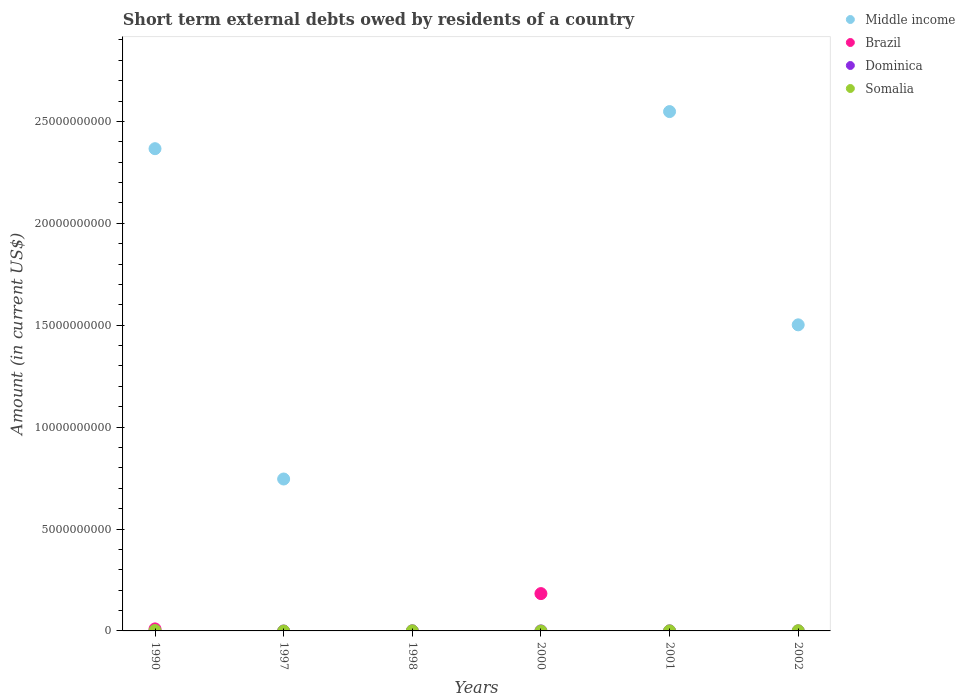How many different coloured dotlines are there?
Your answer should be compact. 4. What is the amount of short-term external debts owed by residents in Middle income in 1997?
Keep it short and to the point. 7.45e+09. Across all years, what is the maximum amount of short-term external debts owed by residents in Somalia?
Provide a short and direct response. 1.77e+07. What is the total amount of short-term external debts owed by residents in Middle income in the graph?
Give a very brief answer. 7.16e+1. What is the difference between the amount of short-term external debts owed by residents in Dominica in 1990 and that in 2001?
Offer a terse response. -2.87e+06. What is the average amount of short-term external debts owed by residents in Somalia per year?
Offer a very short reply. 5.63e+06. In the year 2002, what is the difference between the amount of short-term external debts owed by residents in Dominica and amount of short-term external debts owed by residents in Middle income?
Provide a short and direct response. -1.50e+1. In how many years, is the amount of short-term external debts owed by residents in Somalia greater than 16000000000 US$?
Provide a succinct answer. 0. What is the ratio of the amount of short-term external debts owed by residents in Dominica in 1990 to that in 2000?
Ensure brevity in your answer.  0.65. Is the difference between the amount of short-term external debts owed by residents in Dominica in 2001 and 2002 greater than the difference between the amount of short-term external debts owed by residents in Middle income in 2001 and 2002?
Provide a short and direct response. No. What is the difference between the highest and the second highest amount of short-term external debts owed by residents in Somalia?
Give a very brief answer. 8.66e+06. What is the difference between the highest and the lowest amount of short-term external debts owed by residents in Somalia?
Give a very brief answer. 1.77e+07. In how many years, is the amount of short-term external debts owed by residents in Brazil greater than the average amount of short-term external debts owed by residents in Brazil taken over all years?
Offer a terse response. 1. Is it the case that in every year, the sum of the amount of short-term external debts owed by residents in Brazil and amount of short-term external debts owed by residents in Dominica  is greater than the sum of amount of short-term external debts owed by residents in Middle income and amount of short-term external debts owed by residents in Somalia?
Your answer should be very brief. No. Is it the case that in every year, the sum of the amount of short-term external debts owed by residents in Somalia and amount of short-term external debts owed by residents in Middle income  is greater than the amount of short-term external debts owed by residents in Dominica?
Your response must be concise. No. How many dotlines are there?
Give a very brief answer. 4. Are the values on the major ticks of Y-axis written in scientific E-notation?
Give a very brief answer. No. Does the graph contain grids?
Make the answer very short. No. How many legend labels are there?
Your response must be concise. 4. How are the legend labels stacked?
Provide a short and direct response. Vertical. What is the title of the graph?
Give a very brief answer. Short term external debts owed by residents of a country. Does "Afghanistan" appear as one of the legend labels in the graph?
Ensure brevity in your answer.  No. What is the label or title of the X-axis?
Make the answer very short. Years. What is the label or title of the Y-axis?
Provide a short and direct response. Amount (in current US$). What is the Amount (in current US$) in Middle income in 1990?
Offer a terse response. 2.37e+1. What is the Amount (in current US$) in Brazil in 1990?
Your response must be concise. 9.90e+07. What is the Amount (in current US$) in Somalia in 1990?
Ensure brevity in your answer.  1.77e+07. What is the Amount (in current US$) in Middle income in 1997?
Ensure brevity in your answer.  7.45e+09. What is the Amount (in current US$) of Somalia in 1997?
Make the answer very short. 0. What is the Amount (in current US$) of Dominica in 1998?
Provide a succinct answer. 5.84e+06. What is the Amount (in current US$) in Brazil in 2000?
Your response must be concise. 1.83e+09. What is the Amount (in current US$) of Middle income in 2001?
Keep it short and to the point. 2.55e+1. What is the Amount (in current US$) of Brazil in 2001?
Your answer should be very brief. 0. What is the Amount (in current US$) in Middle income in 2002?
Provide a succinct answer. 1.50e+1. What is the Amount (in current US$) in Dominica in 2002?
Provide a short and direct response. 1.50e+06. What is the Amount (in current US$) in Somalia in 2002?
Give a very brief answer. 9.06e+06. Across all years, what is the maximum Amount (in current US$) in Middle income?
Keep it short and to the point. 2.55e+1. Across all years, what is the maximum Amount (in current US$) of Brazil?
Your answer should be compact. 1.83e+09. Across all years, what is the maximum Amount (in current US$) in Dominica?
Offer a terse response. 5.84e+06. Across all years, what is the maximum Amount (in current US$) in Somalia?
Provide a succinct answer. 1.77e+07. Across all years, what is the minimum Amount (in current US$) of Middle income?
Provide a short and direct response. 0. Across all years, what is the minimum Amount (in current US$) in Brazil?
Your answer should be compact. 0. Across all years, what is the minimum Amount (in current US$) in Dominica?
Provide a short and direct response. 0. What is the total Amount (in current US$) in Middle income in the graph?
Offer a very short reply. 7.16e+1. What is the total Amount (in current US$) in Brazil in the graph?
Give a very brief answer. 1.93e+09. What is the total Amount (in current US$) in Dominica in the graph?
Offer a terse response. 1.07e+07. What is the total Amount (in current US$) of Somalia in the graph?
Give a very brief answer. 3.38e+07. What is the difference between the Amount (in current US$) of Middle income in 1990 and that in 1997?
Your response must be concise. 1.62e+1. What is the difference between the Amount (in current US$) in Dominica in 1990 and that in 1998?
Make the answer very short. -5.71e+06. What is the difference between the Amount (in current US$) of Somalia in 1990 and that in 1998?
Give a very brief answer. 1.27e+07. What is the difference between the Amount (in current US$) in Brazil in 1990 and that in 2000?
Make the answer very short. -1.73e+09. What is the difference between the Amount (in current US$) in Middle income in 1990 and that in 2001?
Offer a terse response. -1.82e+09. What is the difference between the Amount (in current US$) of Dominica in 1990 and that in 2001?
Make the answer very short. -2.87e+06. What is the difference between the Amount (in current US$) of Somalia in 1990 and that in 2001?
Provide a short and direct response. 1.57e+07. What is the difference between the Amount (in current US$) in Middle income in 1990 and that in 2002?
Provide a short and direct response. 8.64e+09. What is the difference between the Amount (in current US$) of Dominica in 1990 and that in 2002?
Offer a very short reply. -1.37e+06. What is the difference between the Amount (in current US$) of Somalia in 1990 and that in 2002?
Offer a terse response. 8.66e+06. What is the difference between the Amount (in current US$) in Middle income in 1997 and that in 2001?
Give a very brief answer. -1.80e+1. What is the difference between the Amount (in current US$) in Middle income in 1997 and that in 2002?
Offer a very short reply. -7.56e+09. What is the difference between the Amount (in current US$) of Dominica in 1998 and that in 2000?
Ensure brevity in your answer.  5.64e+06. What is the difference between the Amount (in current US$) in Dominica in 1998 and that in 2001?
Give a very brief answer. 2.84e+06. What is the difference between the Amount (in current US$) of Dominica in 1998 and that in 2002?
Provide a succinct answer. 4.34e+06. What is the difference between the Amount (in current US$) of Somalia in 1998 and that in 2002?
Provide a succinct answer. -4.06e+06. What is the difference between the Amount (in current US$) of Dominica in 2000 and that in 2001?
Offer a very short reply. -2.80e+06. What is the difference between the Amount (in current US$) of Dominica in 2000 and that in 2002?
Ensure brevity in your answer.  -1.30e+06. What is the difference between the Amount (in current US$) of Middle income in 2001 and that in 2002?
Provide a short and direct response. 1.05e+1. What is the difference between the Amount (in current US$) of Dominica in 2001 and that in 2002?
Ensure brevity in your answer.  1.50e+06. What is the difference between the Amount (in current US$) of Somalia in 2001 and that in 2002?
Provide a succinct answer. -7.06e+06. What is the difference between the Amount (in current US$) in Middle income in 1990 and the Amount (in current US$) in Dominica in 1998?
Make the answer very short. 2.37e+1. What is the difference between the Amount (in current US$) of Middle income in 1990 and the Amount (in current US$) of Somalia in 1998?
Offer a very short reply. 2.37e+1. What is the difference between the Amount (in current US$) in Brazil in 1990 and the Amount (in current US$) in Dominica in 1998?
Your answer should be very brief. 9.32e+07. What is the difference between the Amount (in current US$) in Brazil in 1990 and the Amount (in current US$) in Somalia in 1998?
Offer a very short reply. 9.40e+07. What is the difference between the Amount (in current US$) of Dominica in 1990 and the Amount (in current US$) of Somalia in 1998?
Give a very brief answer. -4.87e+06. What is the difference between the Amount (in current US$) of Middle income in 1990 and the Amount (in current US$) of Brazil in 2000?
Make the answer very short. 2.18e+1. What is the difference between the Amount (in current US$) in Middle income in 1990 and the Amount (in current US$) in Dominica in 2000?
Your answer should be compact. 2.37e+1. What is the difference between the Amount (in current US$) of Brazil in 1990 and the Amount (in current US$) of Dominica in 2000?
Give a very brief answer. 9.88e+07. What is the difference between the Amount (in current US$) of Middle income in 1990 and the Amount (in current US$) of Dominica in 2001?
Your answer should be very brief. 2.37e+1. What is the difference between the Amount (in current US$) of Middle income in 1990 and the Amount (in current US$) of Somalia in 2001?
Give a very brief answer. 2.37e+1. What is the difference between the Amount (in current US$) of Brazil in 1990 and the Amount (in current US$) of Dominica in 2001?
Your answer should be compact. 9.60e+07. What is the difference between the Amount (in current US$) in Brazil in 1990 and the Amount (in current US$) in Somalia in 2001?
Provide a short and direct response. 9.70e+07. What is the difference between the Amount (in current US$) of Dominica in 1990 and the Amount (in current US$) of Somalia in 2001?
Give a very brief answer. -1.87e+06. What is the difference between the Amount (in current US$) in Middle income in 1990 and the Amount (in current US$) in Dominica in 2002?
Your answer should be very brief. 2.37e+1. What is the difference between the Amount (in current US$) in Middle income in 1990 and the Amount (in current US$) in Somalia in 2002?
Make the answer very short. 2.37e+1. What is the difference between the Amount (in current US$) in Brazil in 1990 and the Amount (in current US$) in Dominica in 2002?
Your response must be concise. 9.75e+07. What is the difference between the Amount (in current US$) of Brazil in 1990 and the Amount (in current US$) of Somalia in 2002?
Your answer should be compact. 8.99e+07. What is the difference between the Amount (in current US$) of Dominica in 1990 and the Amount (in current US$) of Somalia in 2002?
Your answer should be very brief. -8.93e+06. What is the difference between the Amount (in current US$) of Middle income in 1997 and the Amount (in current US$) of Dominica in 1998?
Offer a very short reply. 7.45e+09. What is the difference between the Amount (in current US$) of Middle income in 1997 and the Amount (in current US$) of Somalia in 1998?
Keep it short and to the point. 7.45e+09. What is the difference between the Amount (in current US$) in Middle income in 1997 and the Amount (in current US$) in Brazil in 2000?
Make the answer very short. 5.62e+09. What is the difference between the Amount (in current US$) of Middle income in 1997 and the Amount (in current US$) of Dominica in 2000?
Provide a succinct answer. 7.45e+09. What is the difference between the Amount (in current US$) of Middle income in 1997 and the Amount (in current US$) of Dominica in 2001?
Ensure brevity in your answer.  7.45e+09. What is the difference between the Amount (in current US$) of Middle income in 1997 and the Amount (in current US$) of Somalia in 2001?
Keep it short and to the point. 7.45e+09. What is the difference between the Amount (in current US$) of Middle income in 1997 and the Amount (in current US$) of Dominica in 2002?
Your answer should be compact. 7.45e+09. What is the difference between the Amount (in current US$) of Middle income in 1997 and the Amount (in current US$) of Somalia in 2002?
Keep it short and to the point. 7.45e+09. What is the difference between the Amount (in current US$) of Dominica in 1998 and the Amount (in current US$) of Somalia in 2001?
Your answer should be very brief. 3.84e+06. What is the difference between the Amount (in current US$) in Dominica in 1998 and the Amount (in current US$) in Somalia in 2002?
Offer a very short reply. -3.22e+06. What is the difference between the Amount (in current US$) in Brazil in 2000 and the Amount (in current US$) in Dominica in 2001?
Your answer should be compact. 1.83e+09. What is the difference between the Amount (in current US$) of Brazil in 2000 and the Amount (in current US$) of Somalia in 2001?
Your response must be concise. 1.83e+09. What is the difference between the Amount (in current US$) in Dominica in 2000 and the Amount (in current US$) in Somalia in 2001?
Make the answer very short. -1.80e+06. What is the difference between the Amount (in current US$) in Brazil in 2000 and the Amount (in current US$) in Dominica in 2002?
Your response must be concise. 1.83e+09. What is the difference between the Amount (in current US$) of Brazil in 2000 and the Amount (in current US$) of Somalia in 2002?
Your response must be concise. 1.82e+09. What is the difference between the Amount (in current US$) in Dominica in 2000 and the Amount (in current US$) in Somalia in 2002?
Ensure brevity in your answer.  -8.86e+06. What is the difference between the Amount (in current US$) of Middle income in 2001 and the Amount (in current US$) of Dominica in 2002?
Your response must be concise. 2.55e+1. What is the difference between the Amount (in current US$) of Middle income in 2001 and the Amount (in current US$) of Somalia in 2002?
Your answer should be very brief. 2.55e+1. What is the difference between the Amount (in current US$) in Dominica in 2001 and the Amount (in current US$) in Somalia in 2002?
Your answer should be compact. -6.06e+06. What is the average Amount (in current US$) of Middle income per year?
Keep it short and to the point. 1.19e+1. What is the average Amount (in current US$) of Brazil per year?
Provide a short and direct response. 3.22e+08. What is the average Amount (in current US$) of Dominica per year?
Offer a terse response. 1.78e+06. What is the average Amount (in current US$) in Somalia per year?
Offer a terse response. 5.63e+06. In the year 1990, what is the difference between the Amount (in current US$) of Middle income and Amount (in current US$) of Brazil?
Ensure brevity in your answer.  2.36e+1. In the year 1990, what is the difference between the Amount (in current US$) of Middle income and Amount (in current US$) of Dominica?
Provide a short and direct response. 2.37e+1. In the year 1990, what is the difference between the Amount (in current US$) of Middle income and Amount (in current US$) of Somalia?
Offer a terse response. 2.36e+1. In the year 1990, what is the difference between the Amount (in current US$) in Brazil and Amount (in current US$) in Dominica?
Ensure brevity in your answer.  9.89e+07. In the year 1990, what is the difference between the Amount (in current US$) of Brazil and Amount (in current US$) of Somalia?
Provide a short and direct response. 8.13e+07. In the year 1990, what is the difference between the Amount (in current US$) of Dominica and Amount (in current US$) of Somalia?
Give a very brief answer. -1.76e+07. In the year 1998, what is the difference between the Amount (in current US$) of Dominica and Amount (in current US$) of Somalia?
Give a very brief answer. 8.40e+05. In the year 2000, what is the difference between the Amount (in current US$) in Brazil and Amount (in current US$) in Dominica?
Your answer should be compact. 1.83e+09. In the year 2001, what is the difference between the Amount (in current US$) in Middle income and Amount (in current US$) in Dominica?
Make the answer very short. 2.55e+1. In the year 2001, what is the difference between the Amount (in current US$) in Middle income and Amount (in current US$) in Somalia?
Give a very brief answer. 2.55e+1. In the year 2001, what is the difference between the Amount (in current US$) of Dominica and Amount (in current US$) of Somalia?
Offer a terse response. 1.00e+06. In the year 2002, what is the difference between the Amount (in current US$) in Middle income and Amount (in current US$) in Dominica?
Offer a terse response. 1.50e+1. In the year 2002, what is the difference between the Amount (in current US$) in Middle income and Amount (in current US$) in Somalia?
Offer a very short reply. 1.50e+1. In the year 2002, what is the difference between the Amount (in current US$) in Dominica and Amount (in current US$) in Somalia?
Your response must be concise. -7.56e+06. What is the ratio of the Amount (in current US$) in Middle income in 1990 to that in 1997?
Provide a succinct answer. 3.17. What is the ratio of the Amount (in current US$) in Dominica in 1990 to that in 1998?
Keep it short and to the point. 0.02. What is the ratio of the Amount (in current US$) in Somalia in 1990 to that in 1998?
Offer a terse response. 3.54. What is the ratio of the Amount (in current US$) in Brazil in 1990 to that in 2000?
Provide a short and direct response. 0.05. What is the ratio of the Amount (in current US$) in Dominica in 1990 to that in 2000?
Make the answer very short. 0.65. What is the ratio of the Amount (in current US$) in Middle income in 1990 to that in 2001?
Offer a very short reply. 0.93. What is the ratio of the Amount (in current US$) of Dominica in 1990 to that in 2001?
Offer a very short reply. 0.04. What is the ratio of the Amount (in current US$) in Somalia in 1990 to that in 2001?
Provide a succinct answer. 8.86. What is the ratio of the Amount (in current US$) in Middle income in 1990 to that in 2002?
Provide a succinct answer. 1.58. What is the ratio of the Amount (in current US$) in Dominica in 1990 to that in 2002?
Offer a terse response. 0.09. What is the ratio of the Amount (in current US$) in Somalia in 1990 to that in 2002?
Keep it short and to the point. 1.96. What is the ratio of the Amount (in current US$) of Middle income in 1997 to that in 2001?
Give a very brief answer. 0.29. What is the ratio of the Amount (in current US$) in Middle income in 1997 to that in 2002?
Offer a terse response. 0.5. What is the ratio of the Amount (in current US$) in Dominica in 1998 to that in 2000?
Ensure brevity in your answer.  29.2. What is the ratio of the Amount (in current US$) of Dominica in 1998 to that in 2001?
Your answer should be compact. 1.95. What is the ratio of the Amount (in current US$) in Somalia in 1998 to that in 2001?
Your answer should be compact. 2.5. What is the ratio of the Amount (in current US$) of Dominica in 1998 to that in 2002?
Provide a short and direct response. 3.89. What is the ratio of the Amount (in current US$) of Somalia in 1998 to that in 2002?
Your answer should be very brief. 0.55. What is the ratio of the Amount (in current US$) of Dominica in 2000 to that in 2001?
Provide a succinct answer. 0.07. What is the ratio of the Amount (in current US$) in Dominica in 2000 to that in 2002?
Your answer should be compact. 0.13. What is the ratio of the Amount (in current US$) in Middle income in 2001 to that in 2002?
Your answer should be compact. 1.7. What is the ratio of the Amount (in current US$) of Dominica in 2001 to that in 2002?
Keep it short and to the point. 2. What is the ratio of the Amount (in current US$) in Somalia in 2001 to that in 2002?
Offer a terse response. 0.22. What is the difference between the highest and the second highest Amount (in current US$) in Middle income?
Give a very brief answer. 1.82e+09. What is the difference between the highest and the second highest Amount (in current US$) of Dominica?
Offer a very short reply. 2.84e+06. What is the difference between the highest and the second highest Amount (in current US$) in Somalia?
Your answer should be compact. 8.66e+06. What is the difference between the highest and the lowest Amount (in current US$) in Middle income?
Provide a succinct answer. 2.55e+1. What is the difference between the highest and the lowest Amount (in current US$) of Brazil?
Make the answer very short. 1.83e+09. What is the difference between the highest and the lowest Amount (in current US$) in Dominica?
Offer a terse response. 5.84e+06. What is the difference between the highest and the lowest Amount (in current US$) of Somalia?
Make the answer very short. 1.77e+07. 